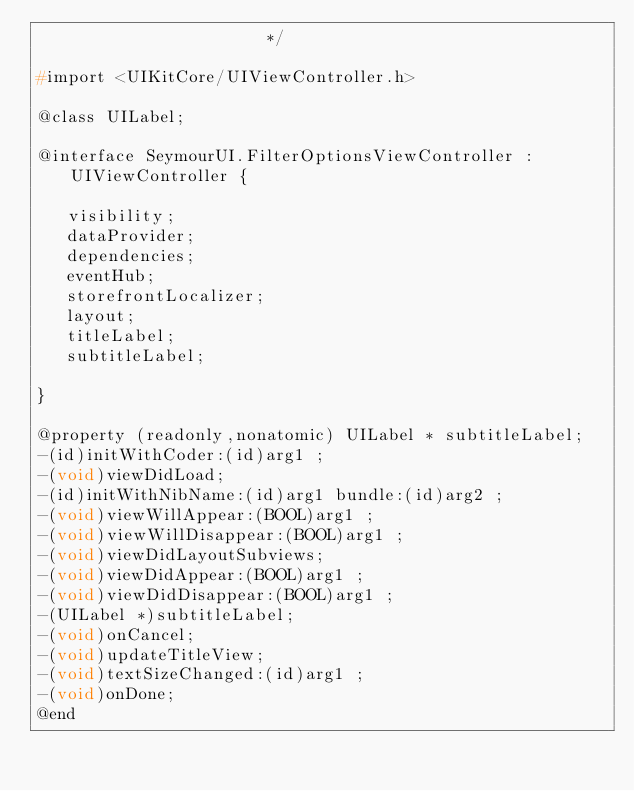Convert code to text. <code><loc_0><loc_0><loc_500><loc_500><_C_>                       */

#import <UIKitCore/UIViewController.h>

@class UILabel;

@interface SeymourUI.FilterOptionsViewController : UIViewController {

	 visibility;
	 dataProvider;
	 dependencies;
	 eventHub;
	 storefrontLocalizer;
	 layout;
	 titleLabel;
	 subtitleLabel;

}

@property (readonly,nonatomic) UILabel * subtitleLabel; 
-(id)initWithCoder:(id)arg1 ;
-(void)viewDidLoad;
-(id)initWithNibName:(id)arg1 bundle:(id)arg2 ;
-(void)viewWillAppear:(BOOL)arg1 ;
-(void)viewWillDisappear:(BOOL)arg1 ;
-(void)viewDidLayoutSubviews;
-(void)viewDidAppear:(BOOL)arg1 ;
-(void)viewDidDisappear:(BOOL)arg1 ;
-(UILabel *)subtitleLabel;
-(void)onCancel;
-(void)updateTitleView;
-(void)textSizeChanged:(id)arg1 ;
-(void)onDone;
@end

</code> 